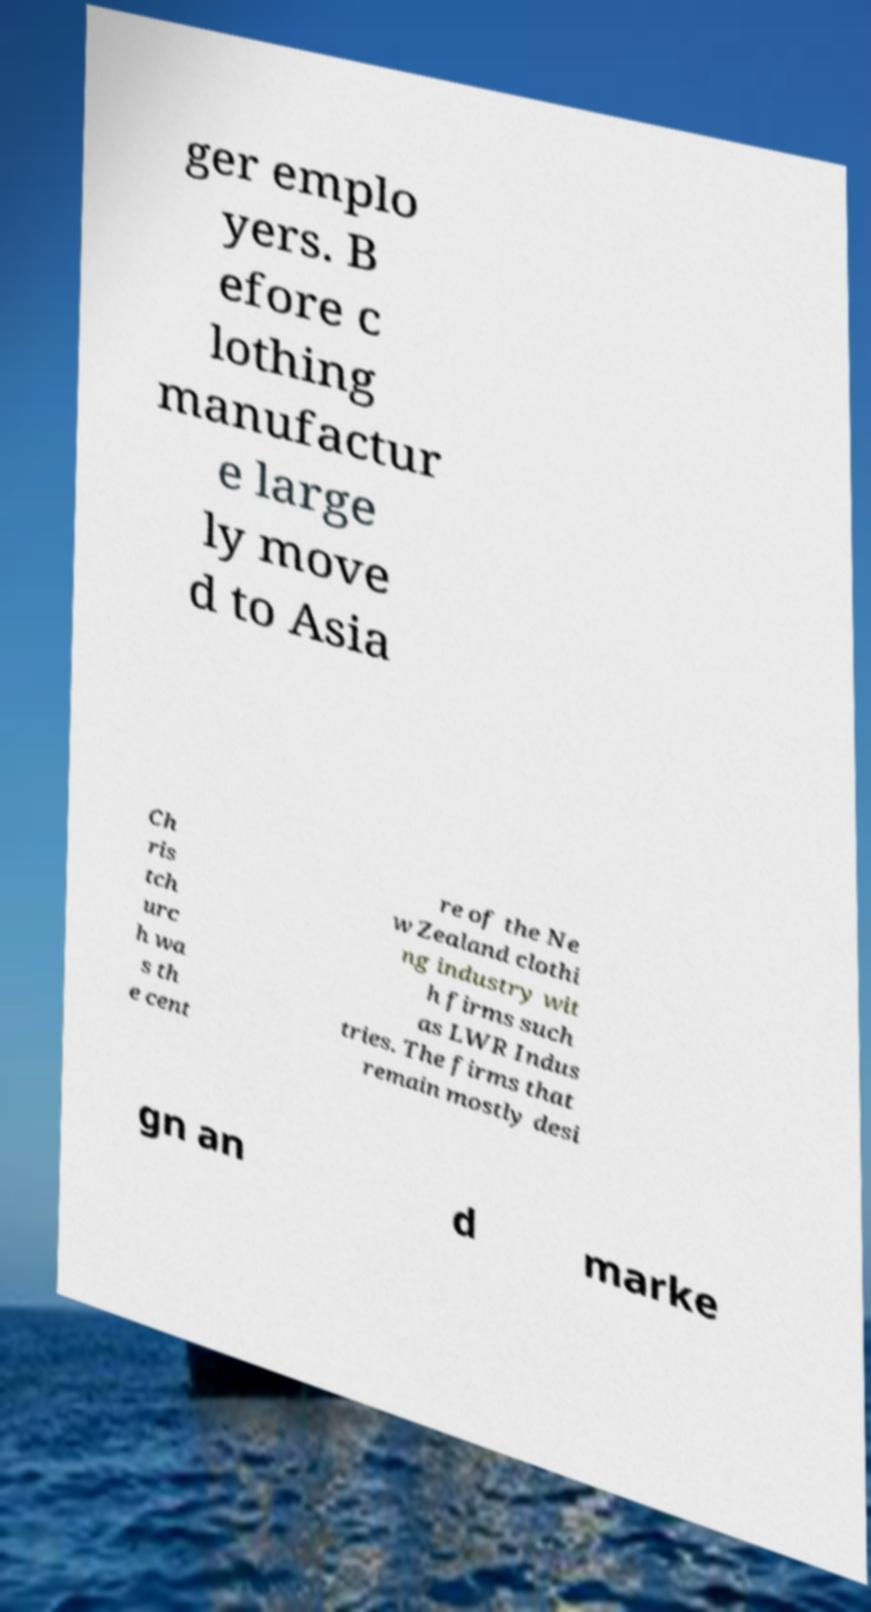For documentation purposes, I need the text within this image transcribed. Could you provide that? ger emplo yers. B efore c lothing manufactur e large ly move d to Asia Ch ris tch urc h wa s th e cent re of the Ne w Zealand clothi ng industry wit h firms such as LWR Indus tries. The firms that remain mostly desi gn an d marke 